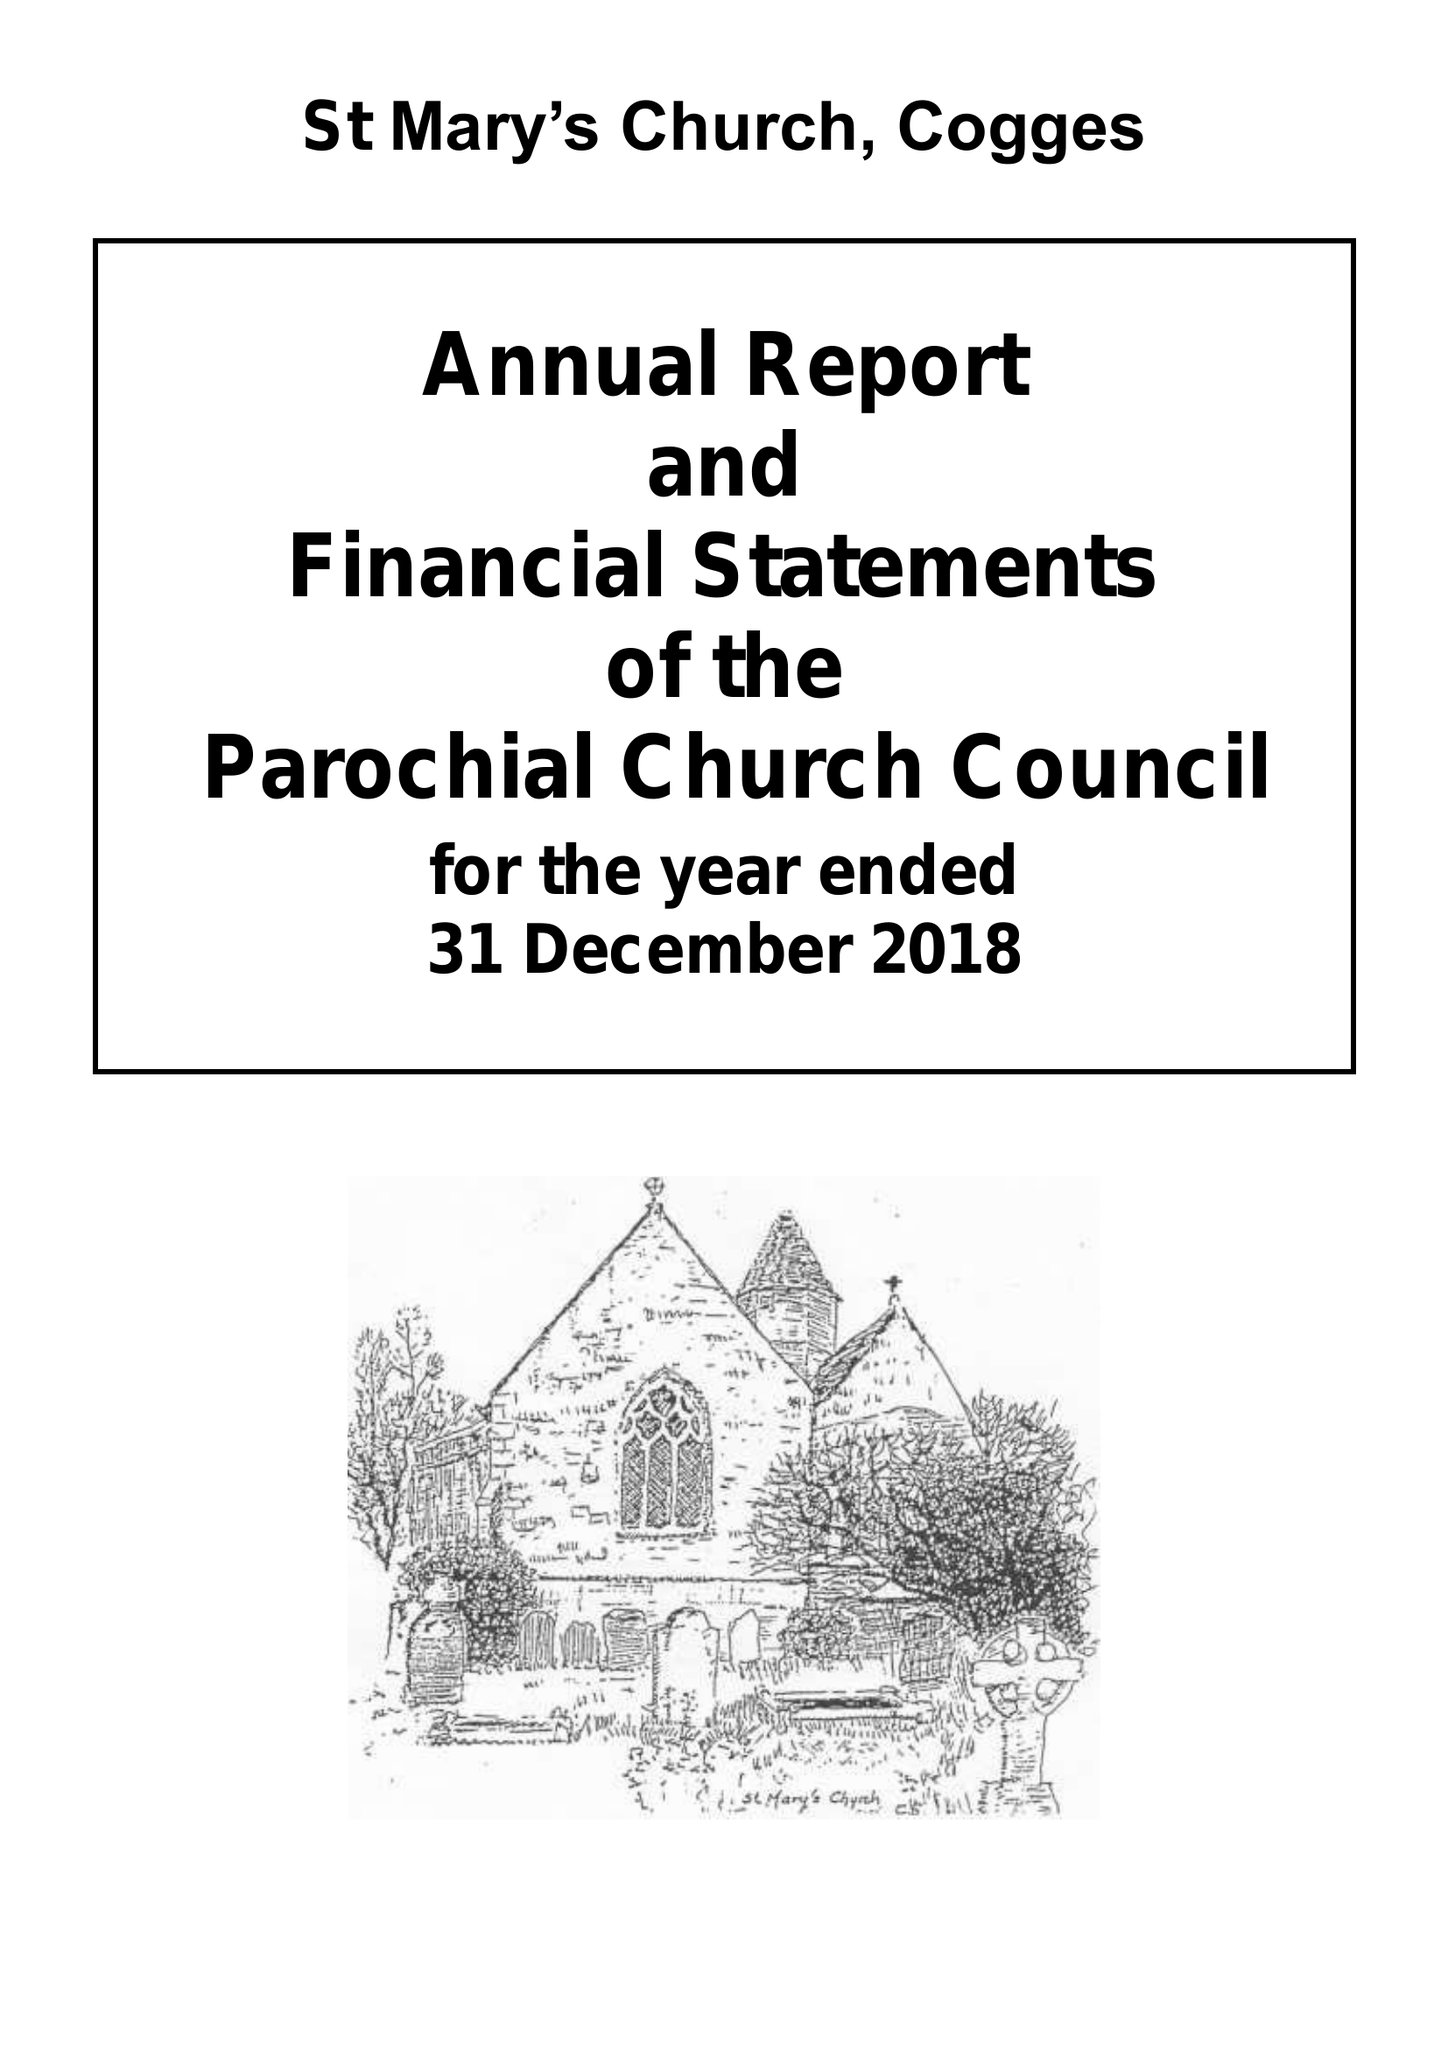What is the value for the address__post_town?
Answer the question using a single word or phrase. WITNEY 